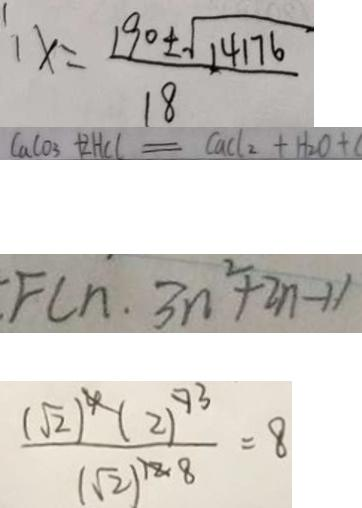<formula> <loc_0><loc_0><loc_500><loc_500>x = \frac { 1 9 0 \pm \sqrt { 1 4 1 7 6 } } { 1 8 } 
 C a C O _ { 3 } + 2 H C l = C a C l _ { 2 } + H _ { 2 } O + 
 F ( n \cdot 3 n ^ { 2 } + 2 n - 1 ) 
 \frac { ( \sqrt { 2 } ) ^ { 4 } ( 2 ) ^ { 7 } } { ( \sqrt { 2 } ) ^ { 1 2 } } = 8</formula> 